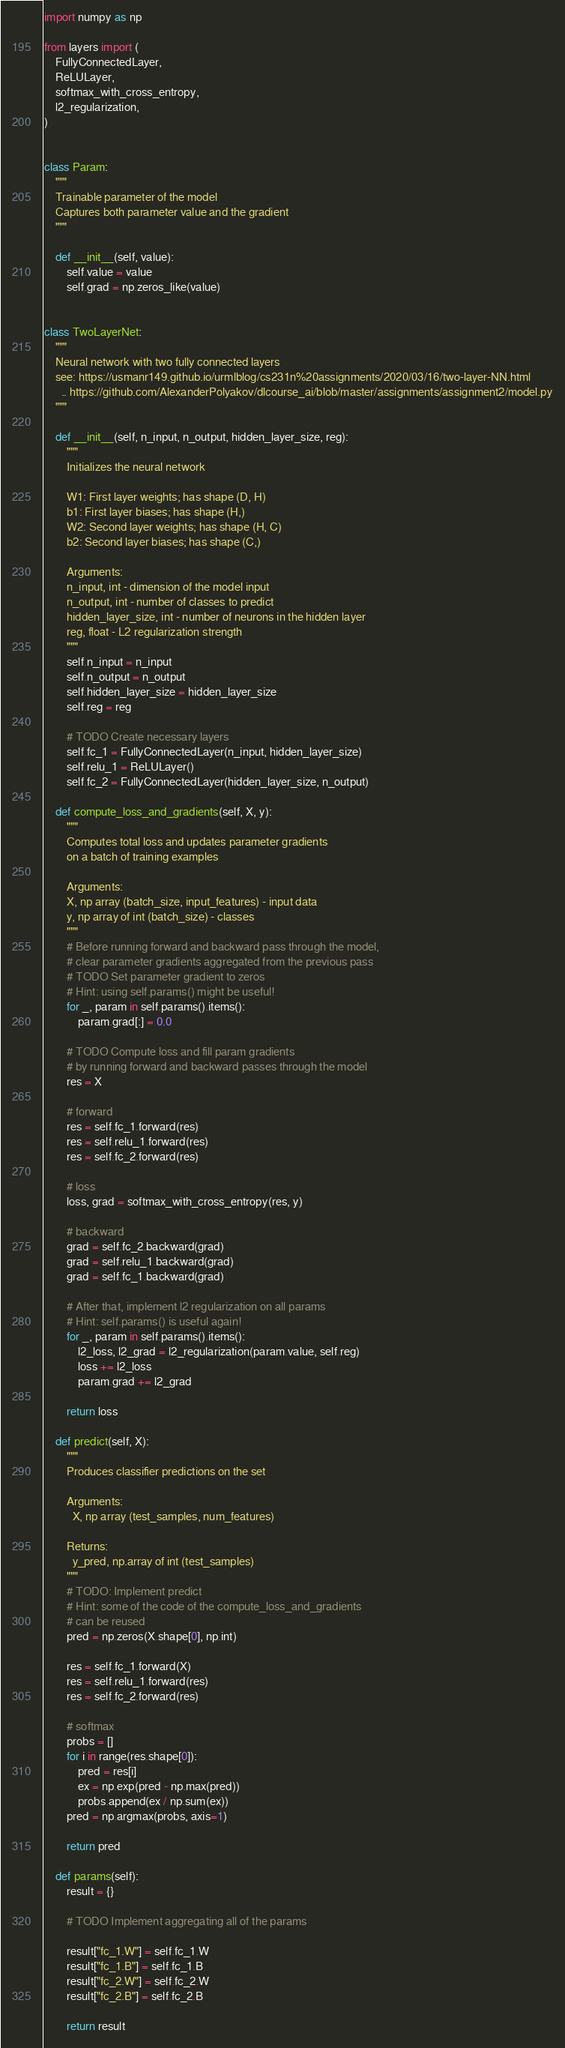Convert code to text. <code><loc_0><loc_0><loc_500><loc_500><_Python_>import numpy as np

from layers import (
    FullyConnectedLayer,
    ReLULayer,
    softmax_with_cross_entropy,
    l2_regularization,
)


class Param:
    """
    Trainable parameter of the model
    Captures both parameter value and the gradient
    """

    def __init__(self, value):
        self.value = value
        self.grad = np.zeros_like(value)


class TwoLayerNet:
    """
    Neural network with two fully connected layers
    see: https://usmanr149.github.io/urmlblog/cs231n%20assignments/2020/03/16/two-layer-NN.html
      .. https://github.com/AlexanderPolyakov/dlcourse_ai/blob/master/assignments/assignment2/model.py
    """

    def __init__(self, n_input, n_output, hidden_layer_size, reg):
        """
        Initializes the neural network

        W1: First layer weights; has shape (D, H)
        b1: First layer biases; has shape (H,)
        W2: Second layer weights; has shape (H, C)
        b2: Second layer biases; has shape (C,)

        Arguments:
        n_input, int - dimension of the model input
        n_output, int - number of classes to predict
        hidden_layer_size, int - number of neurons in the hidden layer
        reg, float - L2 regularization strength
        """
        self.n_input = n_input
        self.n_output = n_output
        self.hidden_layer_size = hidden_layer_size
        self.reg = reg

        # TODO Create necessary layers
        self.fc_1 = FullyConnectedLayer(n_input, hidden_layer_size)
        self.relu_1 = ReLULayer()
        self.fc_2 = FullyConnectedLayer(hidden_layer_size, n_output)

    def compute_loss_and_gradients(self, X, y):
        """
        Computes total loss and updates parameter gradients
        on a batch of training examples

        Arguments:
        X, np array (batch_size, input_features) - input data
        y, np array of int (batch_size) - classes
        """
        # Before running forward and backward pass through the model,
        # clear parameter gradients aggregated from the previous pass
        # TODO Set parameter gradient to zeros
        # Hint: using self.params() might be useful!
        for _, param in self.params().items():
            param.grad[:] = 0.0

        # TODO Compute loss and fill param gradients
        # by running forward and backward passes through the model
        res = X

        # forward
        res = self.fc_1.forward(res)
        res = self.relu_1.forward(res)
        res = self.fc_2.forward(res)

        # loss
        loss, grad = softmax_with_cross_entropy(res, y)

        # backward
        grad = self.fc_2.backward(grad)
        grad = self.relu_1.backward(grad)
        grad = self.fc_1.backward(grad)

        # After that, implement l2 regularization on all params
        # Hint: self.params() is useful again!
        for _, param in self.params().items():
            l2_loss, l2_grad = l2_regularization(param.value, self.reg)
            loss += l2_loss
            param.grad += l2_grad

        return loss

    def predict(self, X):
        """
        Produces classifier predictions on the set

        Arguments:
          X, np array (test_samples, num_features)

        Returns:
          y_pred, np.array of int (test_samples)
        """
        # TODO: Implement predict
        # Hint: some of the code of the compute_loss_and_gradients
        # can be reused
        pred = np.zeros(X.shape[0], np.int)

        res = self.fc_1.forward(X)
        res = self.relu_1.forward(res)
        res = self.fc_2.forward(res)

        # softmax
        probs = []
        for i in range(res.shape[0]):
            pred = res[i]
            ex = np.exp(pred - np.max(pred))
            probs.append(ex / np.sum(ex))
        pred = np.argmax(probs, axis=1)

        return pred

    def params(self):
        result = {}

        # TODO Implement aggregating all of the params

        result["fc_1.W"] = self.fc_1.W
        result["fc_1.B"] = self.fc_1.B
        result["fc_2.W"] = self.fc_2.W
        result["fc_2.B"] = self.fc_2.B

        return result
</code> 